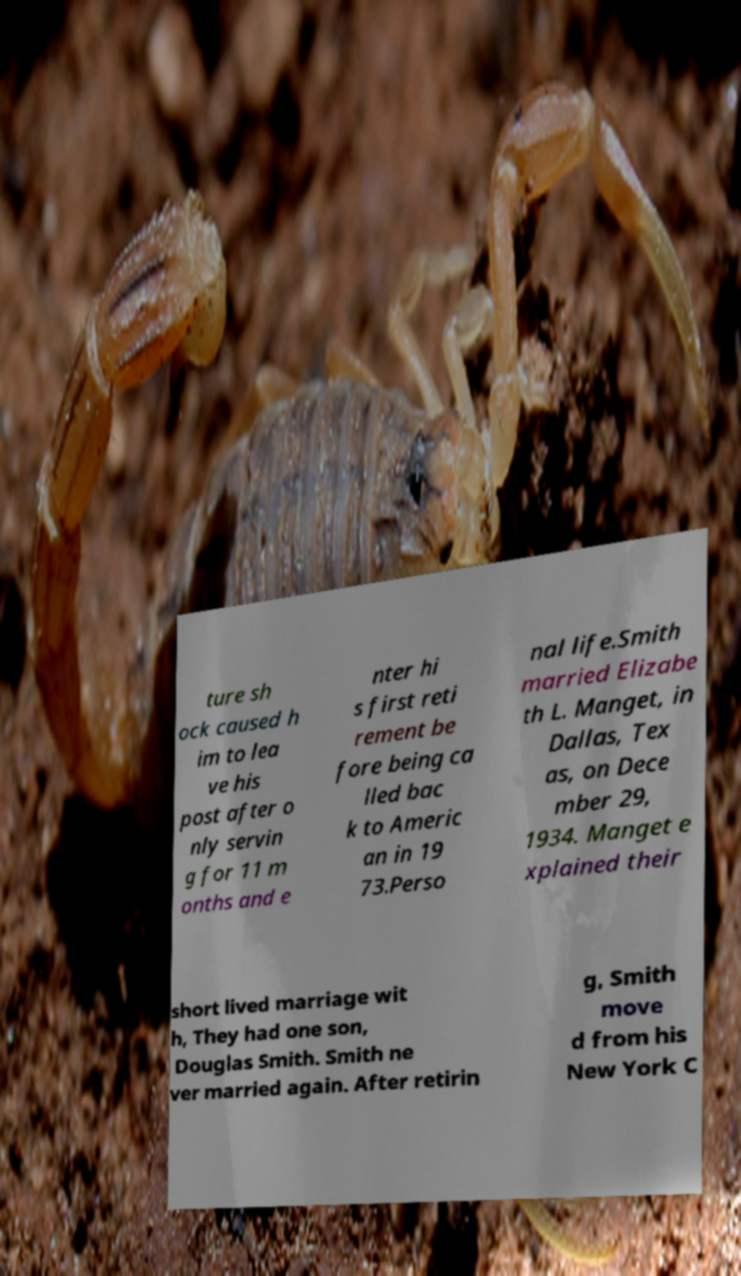Could you extract and type out the text from this image? ture sh ock caused h im to lea ve his post after o nly servin g for 11 m onths and e nter hi s first reti rement be fore being ca lled bac k to Americ an in 19 73.Perso nal life.Smith married Elizabe th L. Manget, in Dallas, Tex as, on Dece mber 29, 1934. Manget e xplained their short lived marriage wit h, They had one son, Douglas Smith. Smith ne ver married again. After retirin g, Smith move d from his New York C 